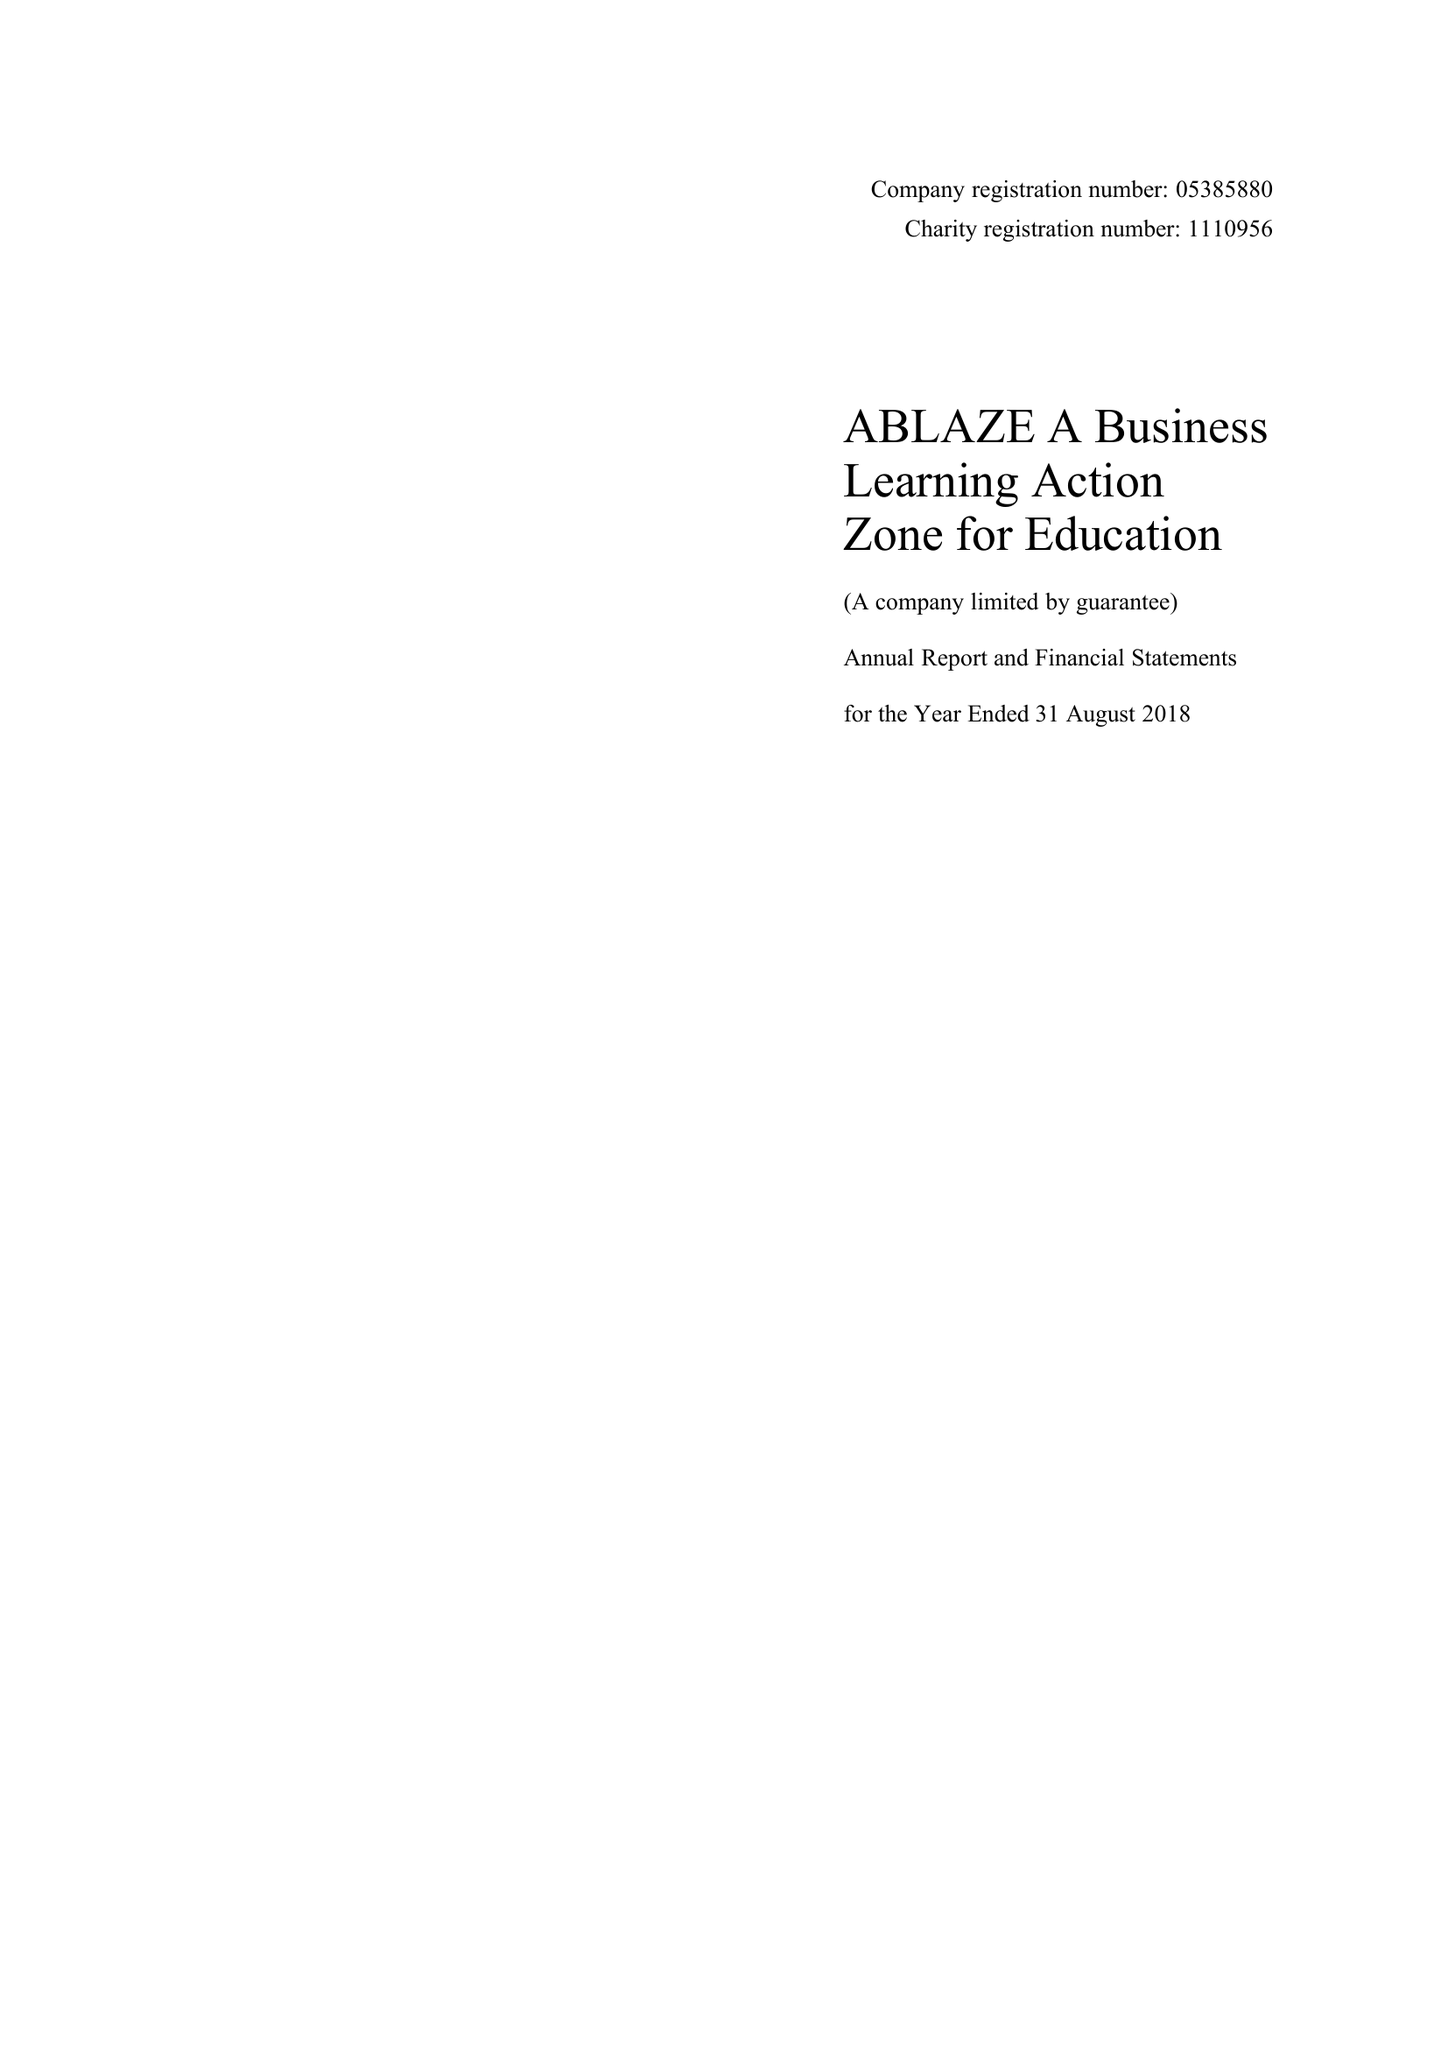What is the value for the address__post_town?
Answer the question using a single word or phrase. BRISTOL 